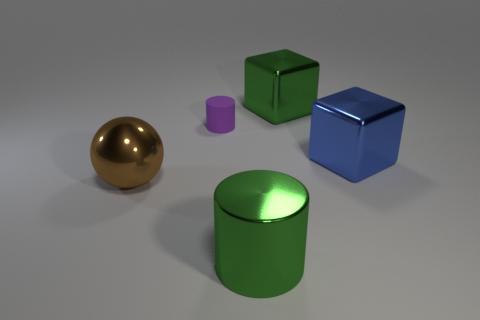The other large metallic thing that is the same shape as the large blue metal object is what color? The other object that shares the same cylindrical shape as the sizable blue metal object is indeed green. It appears to have a glossy finish and reflects light similarly to the blue object, highlighting its smooth surface and the consistent quality of materials used in both objects. 